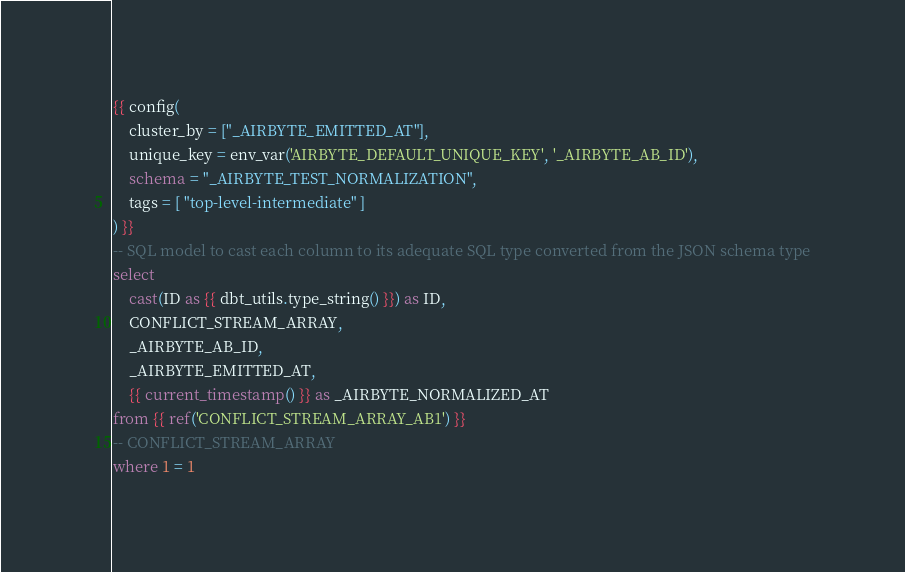Convert code to text. <code><loc_0><loc_0><loc_500><loc_500><_SQL_>{{ config(
    cluster_by = ["_AIRBYTE_EMITTED_AT"],
    unique_key = env_var('AIRBYTE_DEFAULT_UNIQUE_KEY', '_AIRBYTE_AB_ID'),
    schema = "_AIRBYTE_TEST_NORMALIZATION",
    tags = [ "top-level-intermediate" ]
) }}
-- SQL model to cast each column to its adequate SQL type converted from the JSON schema type
select
    cast(ID as {{ dbt_utils.type_string() }}) as ID,
    CONFLICT_STREAM_ARRAY,
    _AIRBYTE_AB_ID,
    _AIRBYTE_EMITTED_AT,
    {{ current_timestamp() }} as _AIRBYTE_NORMALIZED_AT
from {{ ref('CONFLICT_STREAM_ARRAY_AB1') }}
-- CONFLICT_STREAM_ARRAY
where 1 = 1

</code> 